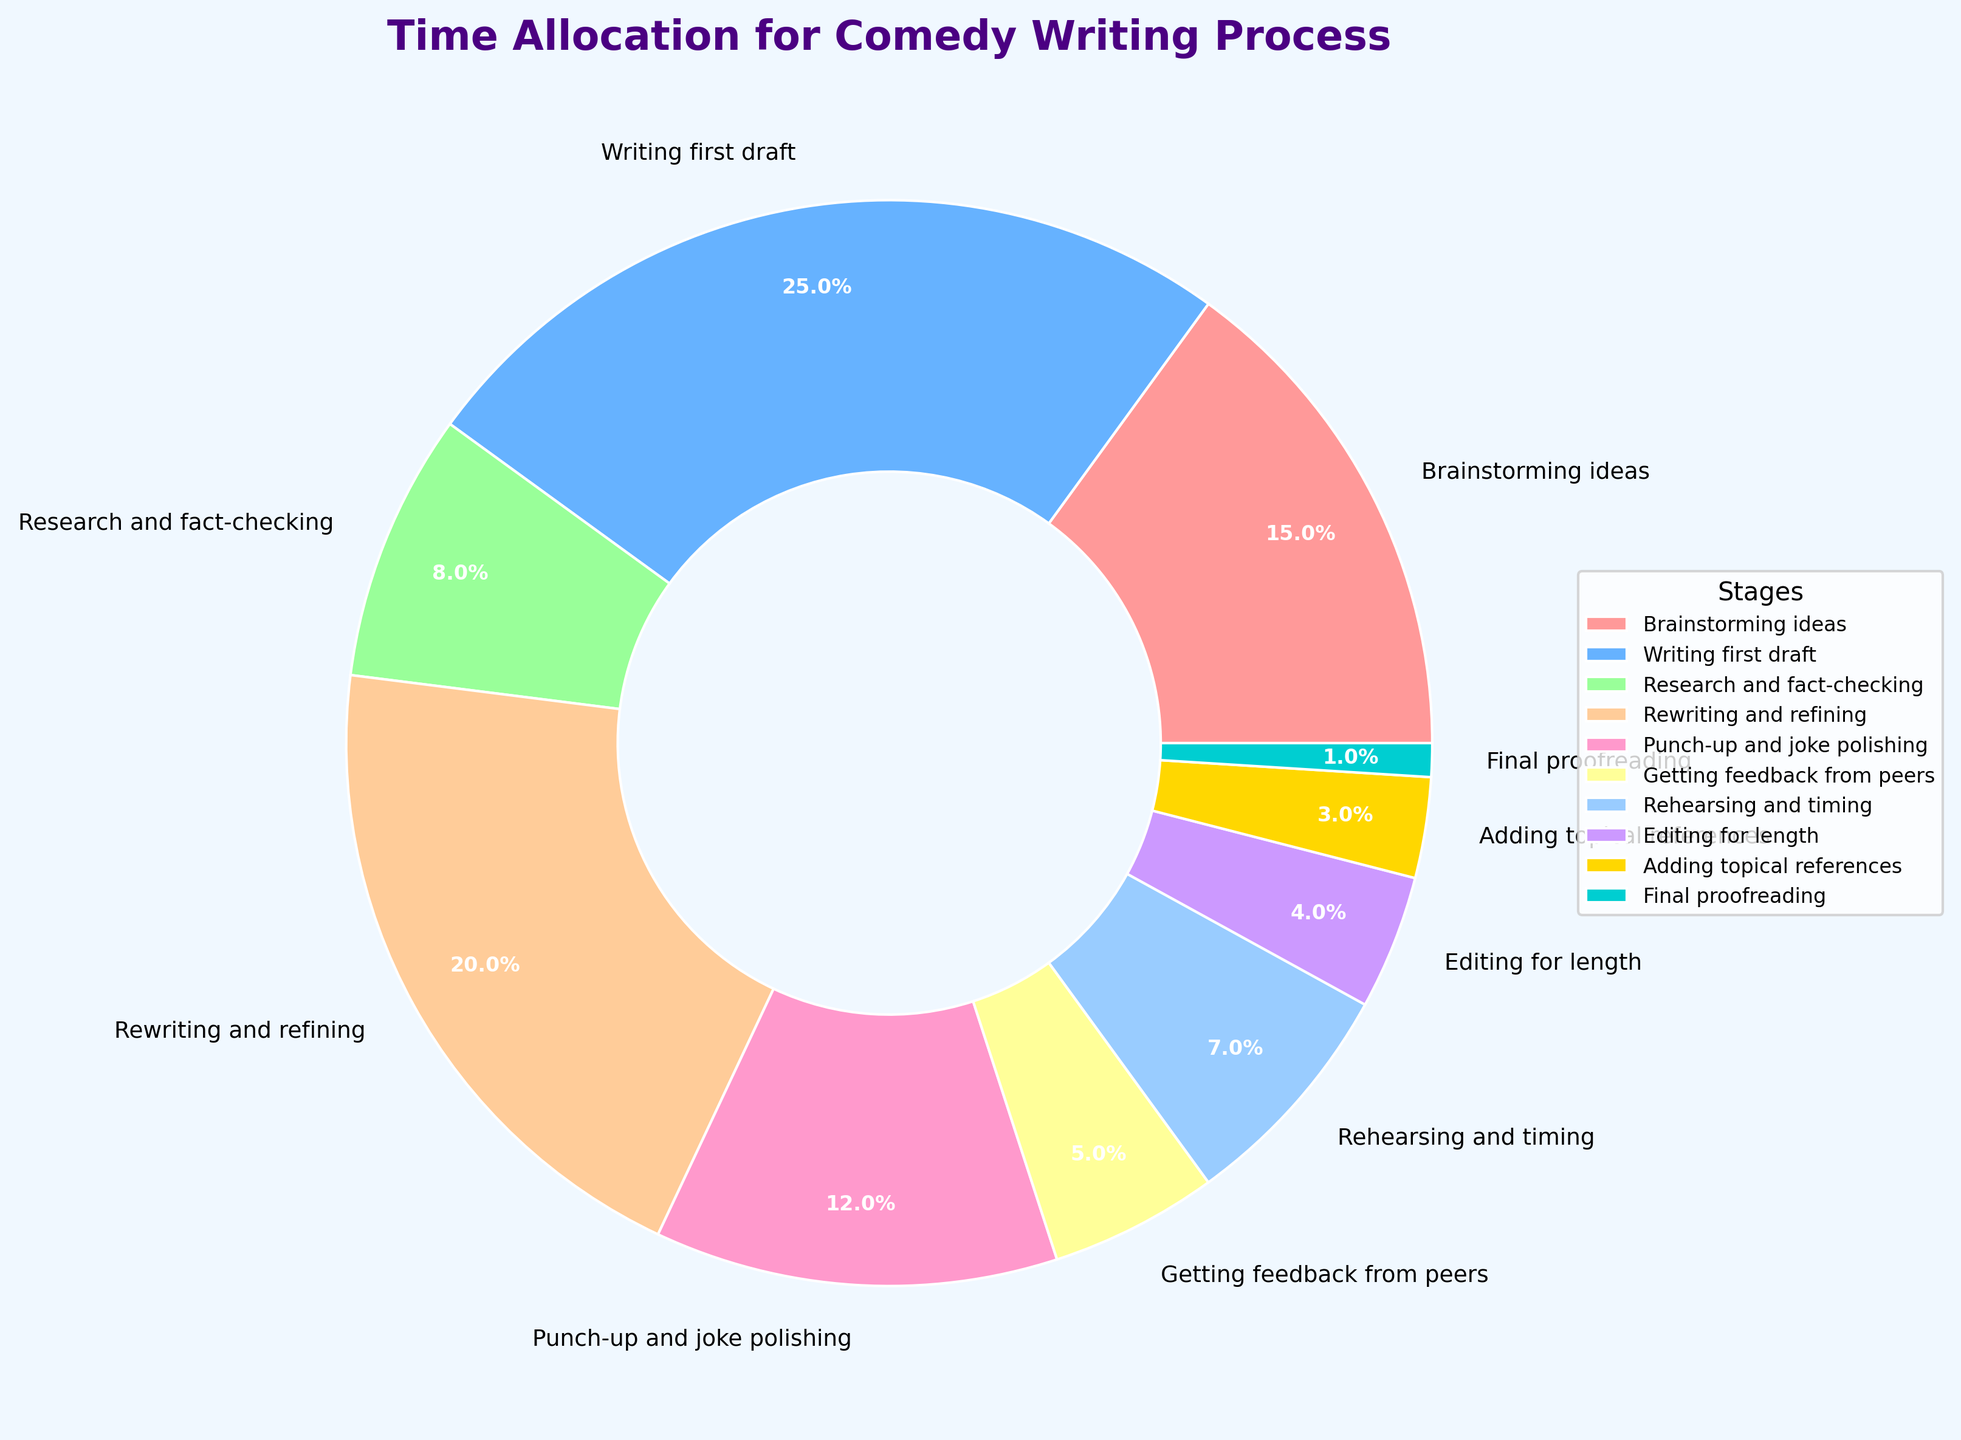What is the largest time allocation stage in the comedy writing process? Identify the segment with the highest percentage. The ‘Writing first draft’ segment occupies the largest portion of the pie chart, indicating 25% of the time allocation.
Answer: Writing first draft How much more time is allocated to 'Rewriting and refining' compared to 'Getting feedback from peers'? Find the percentages for both stages: 'Rewriting and refining' (20%) and 'Getting feedback from peers' (5%). Subtract the smaller percentage from the larger one: 20% - 5% = 15%.
Answer: 15% What percentage of time is spent on both 'Brainstorming ideas' and 'Research and fact-checking' combined? Add the percentages of the two stages: 'Brainstorming ideas' (15%) and 'Research and fact-checking' (8%). The combined percentage is 15% + 8% = 23%.
Answer: 23% Which stage has the smallest time allocation? Locate the segment with the smallest percentage. The 'Final proofreading' stage has the smallest allocation at 1%.
Answer: Final proofreading What is the sum of the percentages for 'Punch-up and joke polishing', 'Editing for length', and 'Adding topical references'? Add the percentages: 'Punch-up and joke polishing' (12%), 'Editing for length' (4%), and 'Adding topical references' (3%). The total is 12% + 4% + 3% = 19%.
Answer: 19% Is more time dedicated to 'Rehearsing and timing' or 'Research and fact-checking'? Compare the percentages of 'Rehearsing and timing' (7%) and 'Research and fact-checking' (8%). 'Research and fact-checking' has a higher percentage.
Answer: Research and fact-checking What color represents 'Writing first draft' in the pie chart? Visually identify the corresponding color for the 'Writing first draft' segment, which is shown in blue.
Answer: Blue How does the time spent on 'Rewriting and refining' compare to the sum of 'Final proofreading' and 'Adding topical references'? Calculate the sum of 'Final proofreading' (1%) and 'Adding topical references' (3%), which is 1% + 3% = 4%. Compare this with 'Rewriting and refining' (20%). The latter is significantly larger.
Answer: Rewriting and refining is larger What is the combined percentage of stages that involve direct content modification ('Writing first draft', 'Rewriting and refining', 'Punch-up and joke polishing', 'Editing for length')? Add the percentages of these stages: 'Writing first draft' (25%), 'Rewriting and refining' (20%), 'Punch-up and joke polishing' (12%), 'Editing for length' (4%). The sum is 25% + 20% + 12% + 4% = 61%.
Answer: 61% What stage is allocated less time than 'Punch-up and joke polishing' but more time than 'Editing for length'? Compare percentages: 'Punch-up and joke polishing' (12%), 'Editing for length' (4%). The stage that falls between these two percentages is 'Rehearsing and timing' (7%).
Answer: Rehearsing and timing 